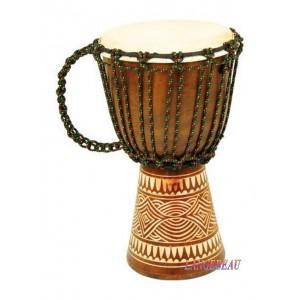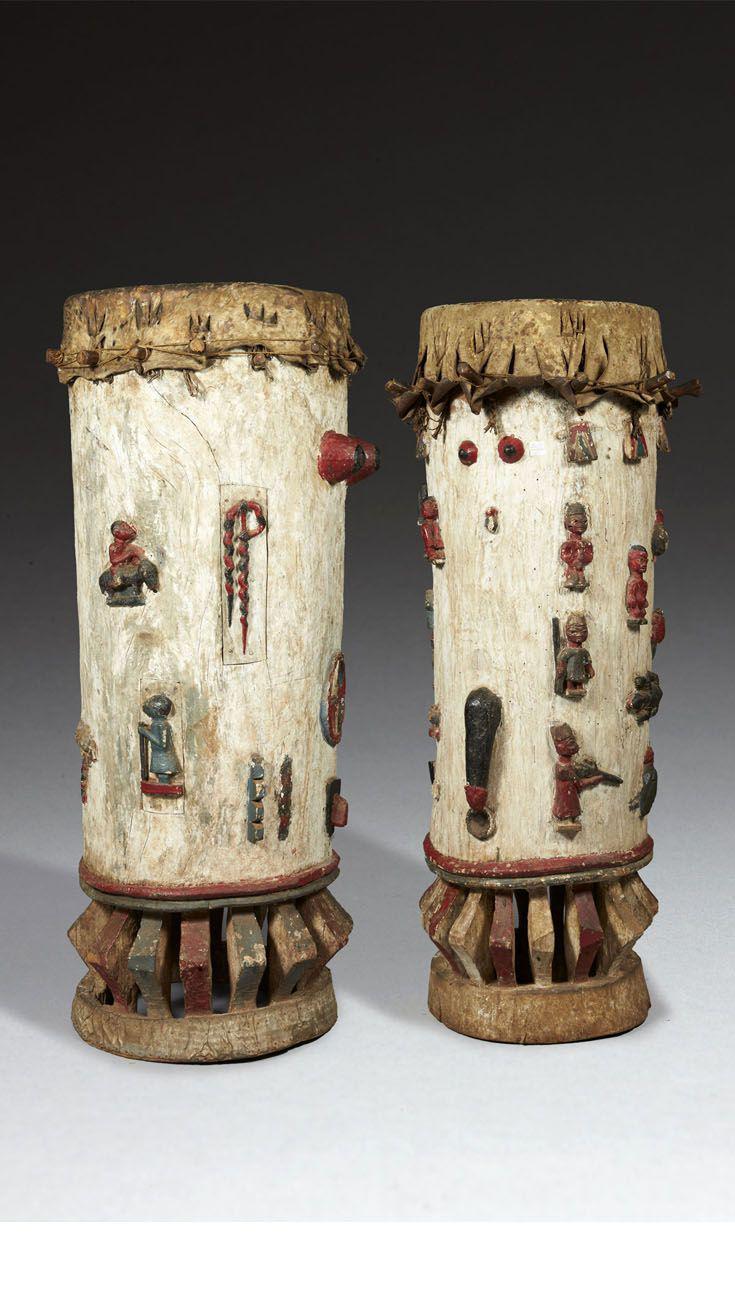The first image is the image on the left, the second image is the image on the right. For the images displayed, is the sentence "There is a single drum in the left image and two drums in the right image." factually correct? Answer yes or no. Yes. The first image is the image on the left, the second image is the image on the right. Assess this claim about the two images: "In at least one image there are duel wooden drums.". Correct or not? Answer yes or no. Yes. 